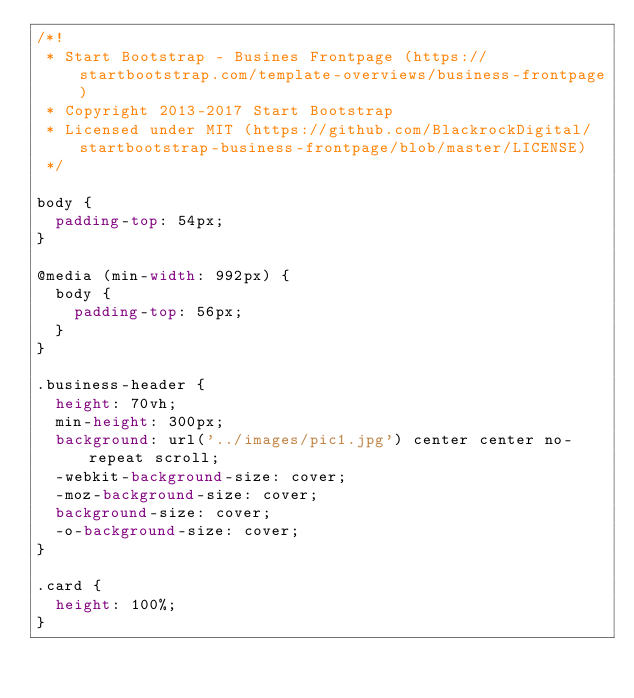Convert code to text. <code><loc_0><loc_0><loc_500><loc_500><_CSS_>/*!
 * Start Bootstrap - Busines Frontpage (https://startbootstrap.com/template-overviews/business-frontpage)
 * Copyright 2013-2017 Start Bootstrap
 * Licensed under MIT (https://github.com/BlackrockDigital/startbootstrap-business-frontpage/blob/master/LICENSE)
 */

body {
  padding-top: 54px;
}

@media (min-width: 992px) {
  body {
    padding-top: 56px;
  }
}

.business-header {
  height: 70vh;
  min-height: 300px;
  background: url('../images/pic1.jpg') center center no-repeat scroll;
  -webkit-background-size: cover;
  -moz-background-size: cover;
  background-size: cover;
  -o-background-size: cover;
}

.card {
  height: 100%;
}
</code> 